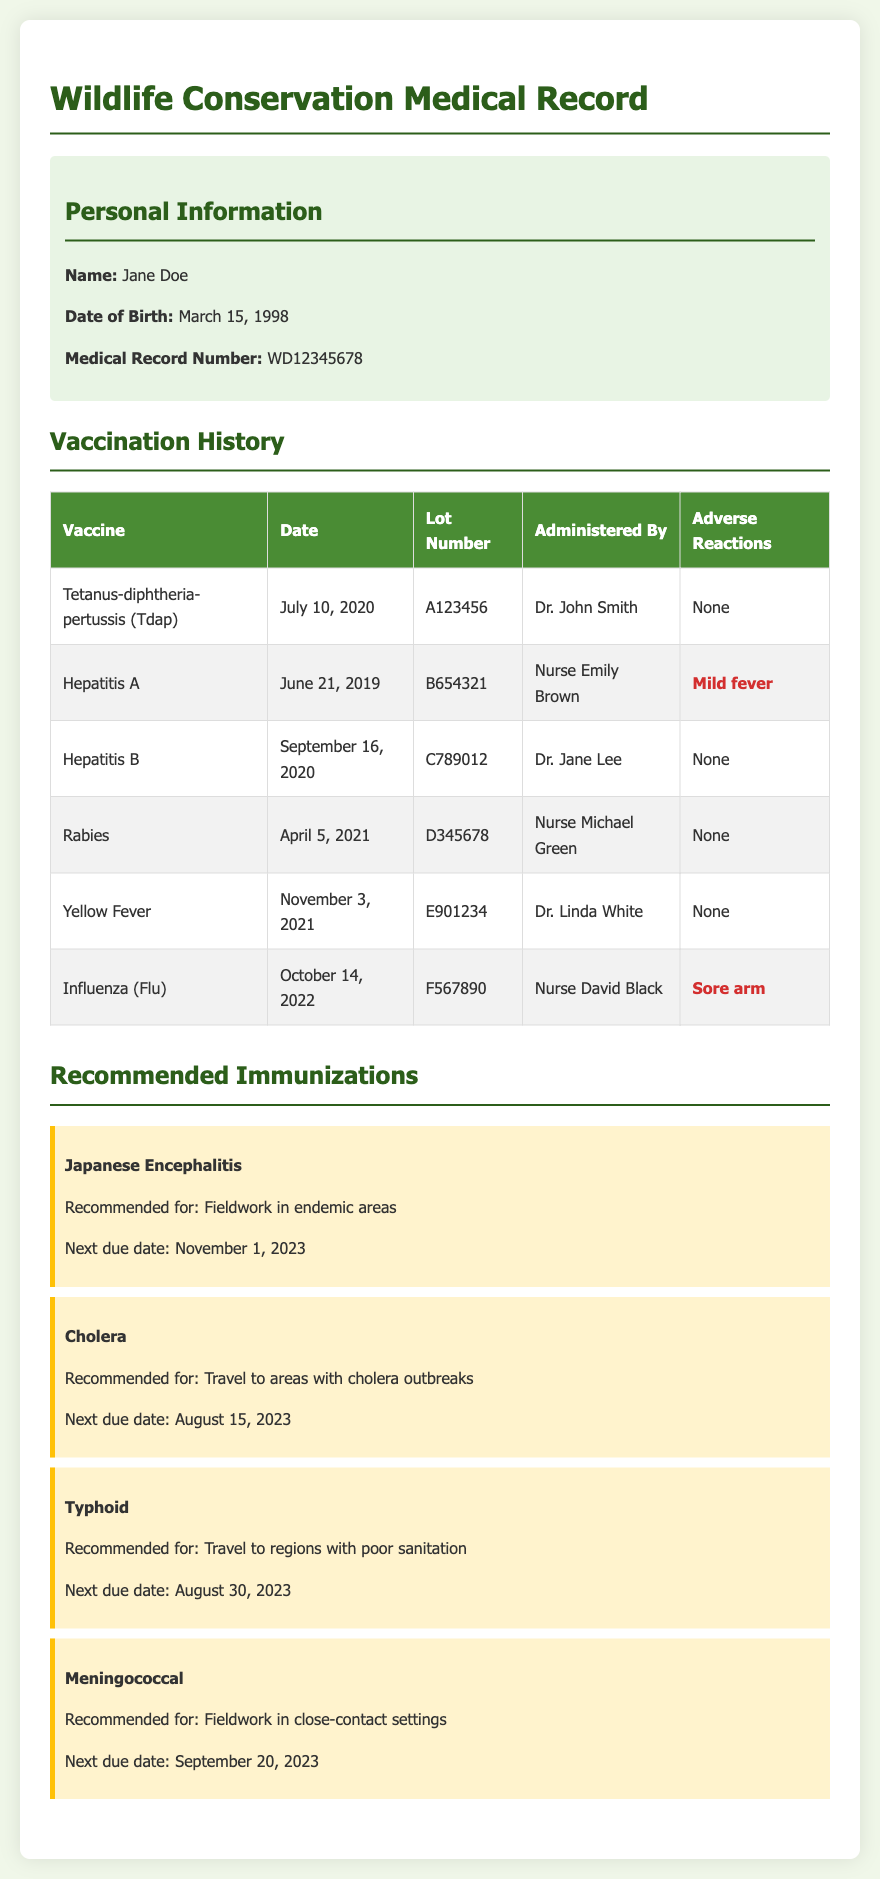What is the name of the individual? The document provides personal information including the individual's name, which is mentioned at the beginning.
Answer: Jane Doe What is the date of birth? The individual's date of birth is specified in the personal information section of the document.
Answer: March 15, 1998 When was the Rabies vaccine administered? The document lists the administration date of the Rabies vaccine in the vaccination history section.
Answer: April 5, 2021 What adverse reaction did the individual have to the Hepatitis A vaccine? The document specifies the adverse reaction associated with the Hepatitis A vaccine in the vaccination history section.
Answer: Mild fever What is the next due date for the Japanese Encephalitis vaccine? The document provides specific due dates for recommended immunizations, including Japanese Encephalitis.
Answer: November 1, 2023 Which vaccine had the lot number E901234? The document lists the lot numbers associated with each vaccine in the vaccination history section.
Answer: Yellow Fever What vaccine is recommended for travel to areas with poor sanitation? The document includes recommendations for immunizations based on field risks, specifying the relevant vaccine.
Answer: Typhoid How many vaccines are listed in the vaccination history? The document enumerates the vaccines administered, which can be counted in the vaccination history section.
Answer: Six 